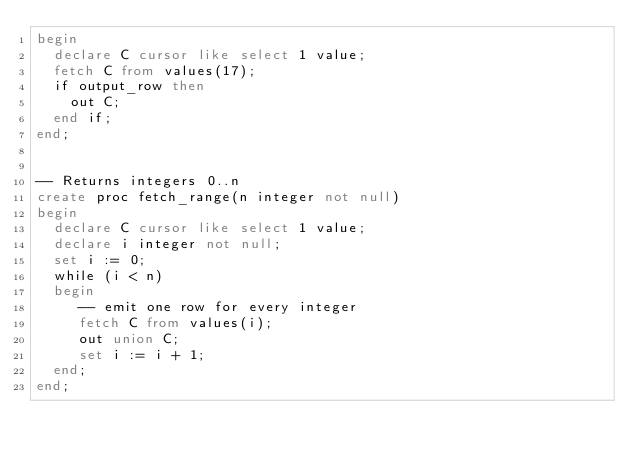Convert code to text. <code><loc_0><loc_0><loc_500><loc_500><_SQL_>begin
  declare C cursor like select 1 value;
  fetch C from values(17);
  if output_row then
    out C;
  end if;
end;


-- Returns integers 0..n
create proc fetch_range(n integer not null)
begin
  declare C cursor like select 1 value;
  declare i integer not null;
  set i := 0;
  while (i < n)
  begin
     -- emit one row for every integer
     fetch C from values(i);
     out union C;
     set i := i + 1;
  end;
end;</code> 